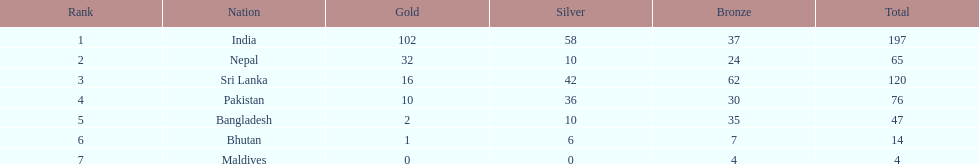Help me parse the entirety of this table. {'header': ['Rank', 'Nation', 'Gold', 'Silver', 'Bronze', 'Total'], 'rows': [['1', 'India', '102', '58', '37', '197'], ['2', 'Nepal', '32', '10', '24', '65'], ['3', 'Sri Lanka', '16', '42', '62', '120'], ['4', 'Pakistan', '10', '36', '30', '76'], ['5', 'Bangladesh', '2', '10', '35', '47'], ['6', 'Bhutan', '1', '6', '7', '14'], ['7', 'Maldives', '0', '0', '4', '4']]} What was the number of silver medals won by pakistan? 36. 